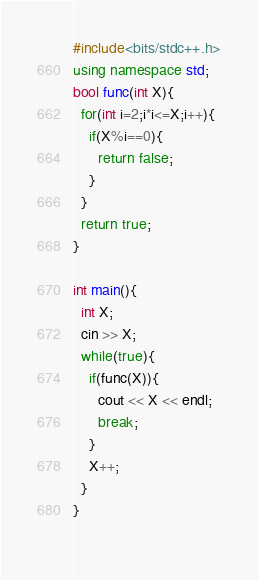Convert code to text. <code><loc_0><loc_0><loc_500><loc_500><_C++_>#include<bits/stdc++.h>
using namespace std;
bool func(int X){
  for(int i=2;i*i<=X;i++){
    if(X%i==0){
      return false;
    }
  }
  return true;
}
  
int main(){
  int X;
  cin >> X;
  while(true){
    if(func(X)){
      cout << X << endl;
      break;
    }
    X++;
  }
}
  </code> 